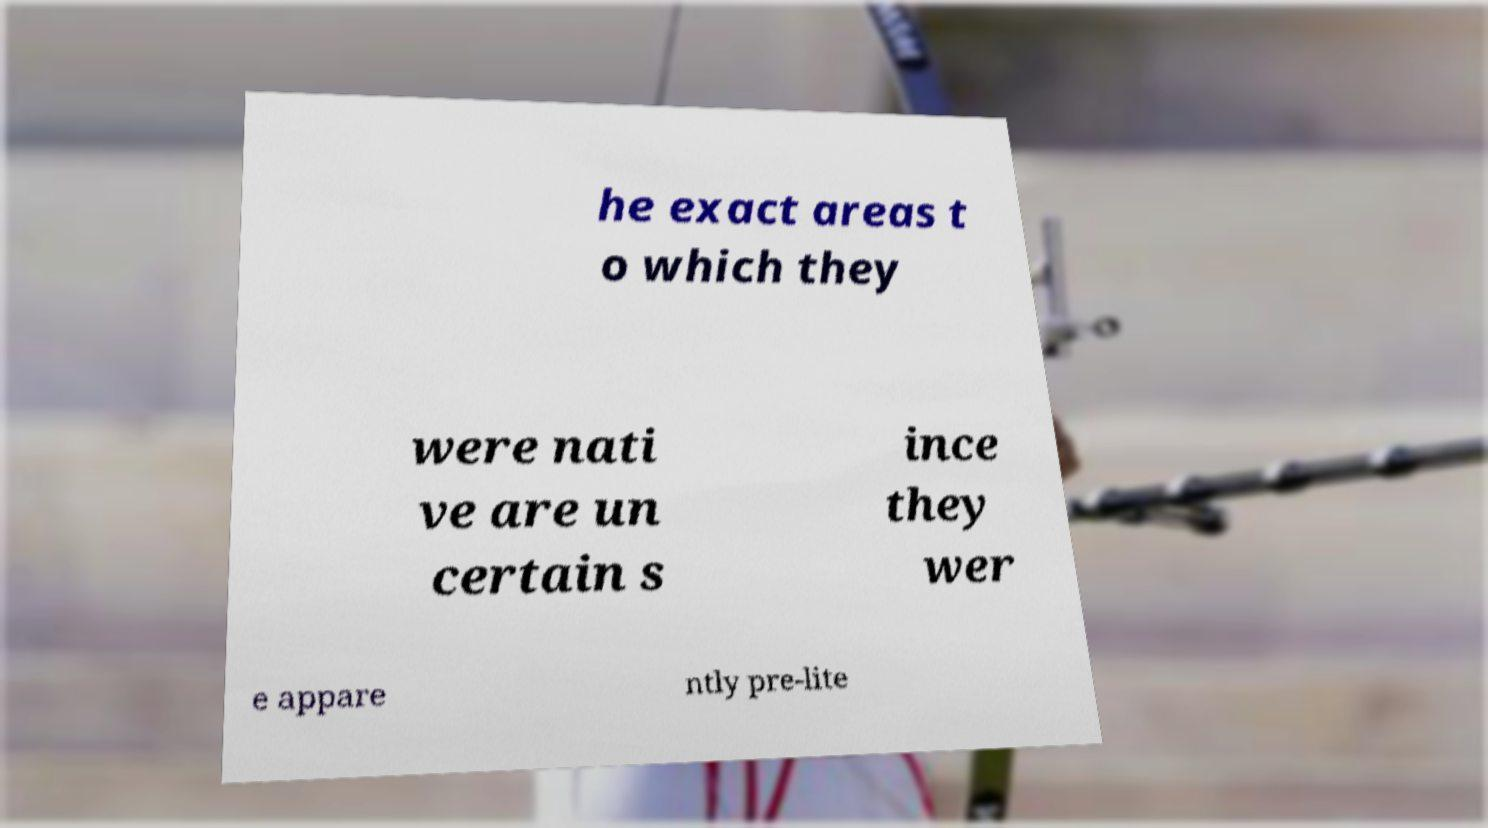For documentation purposes, I need the text within this image transcribed. Could you provide that? he exact areas t o which they were nati ve are un certain s ince they wer e appare ntly pre-lite 